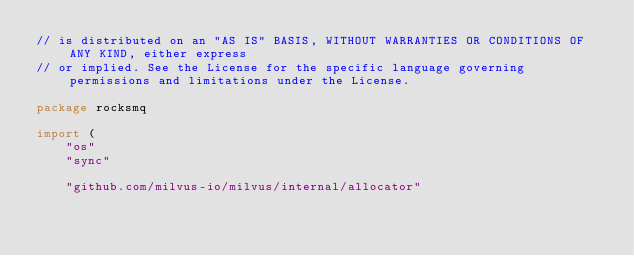Convert code to text. <code><loc_0><loc_0><loc_500><loc_500><_Go_>// is distributed on an "AS IS" BASIS, WITHOUT WARRANTIES OR CONDITIONS OF ANY KIND, either express
// or implied. See the License for the specific language governing permissions and limitations under the License.

package rocksmq

import (
	"os"
	"sync"

	"github.com/milvus-io/milvus/internal/allocator"
</code> 